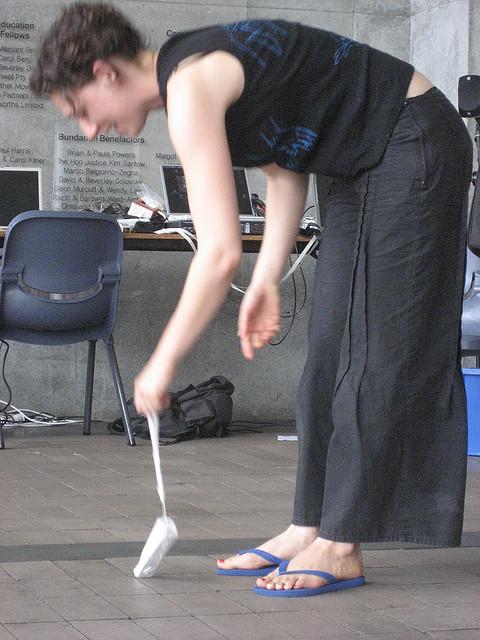What color are the woman's pants?
Quick response, please. Gray. Is the person wearing a bracelet?
Be succinct. No. What color is the woman's flip-flops?
Be succinct. Blue. What is the woman holding?
Concise answer only. Wii controller. 